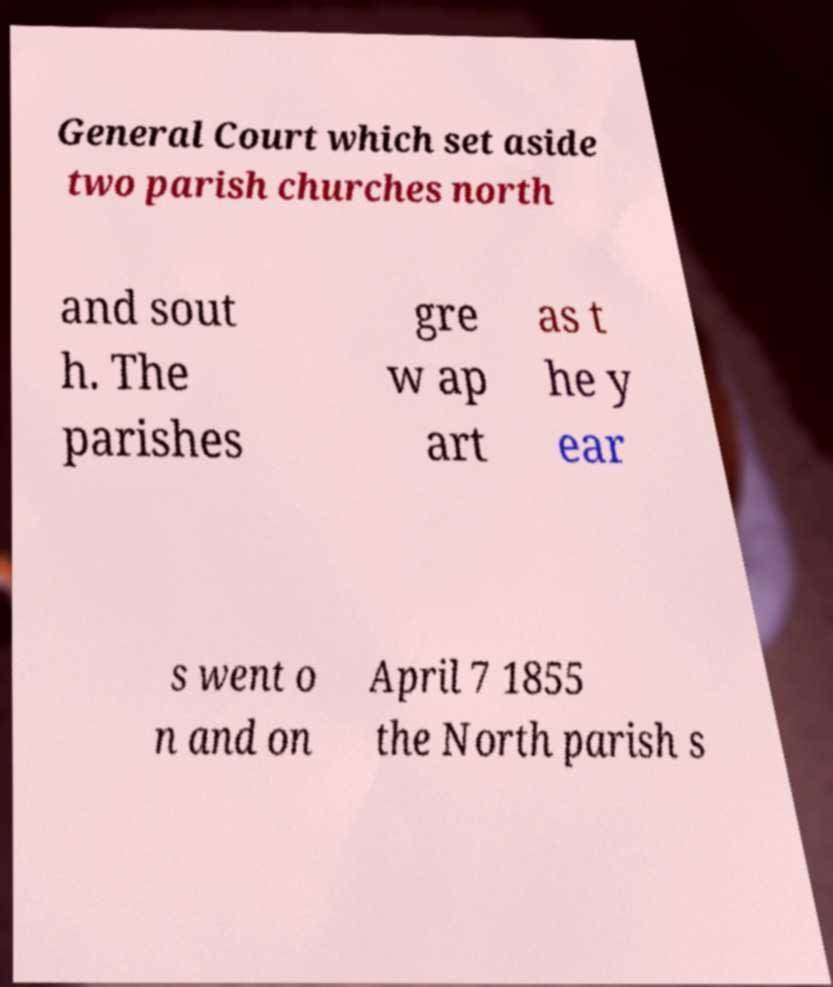Can you accurately transcribe the text from the provided image for me? General Court which set aside two parish churches north and sout h. The parishes gre w ap art as t he y ear s went o n and on April 7 1855 the North parish s 